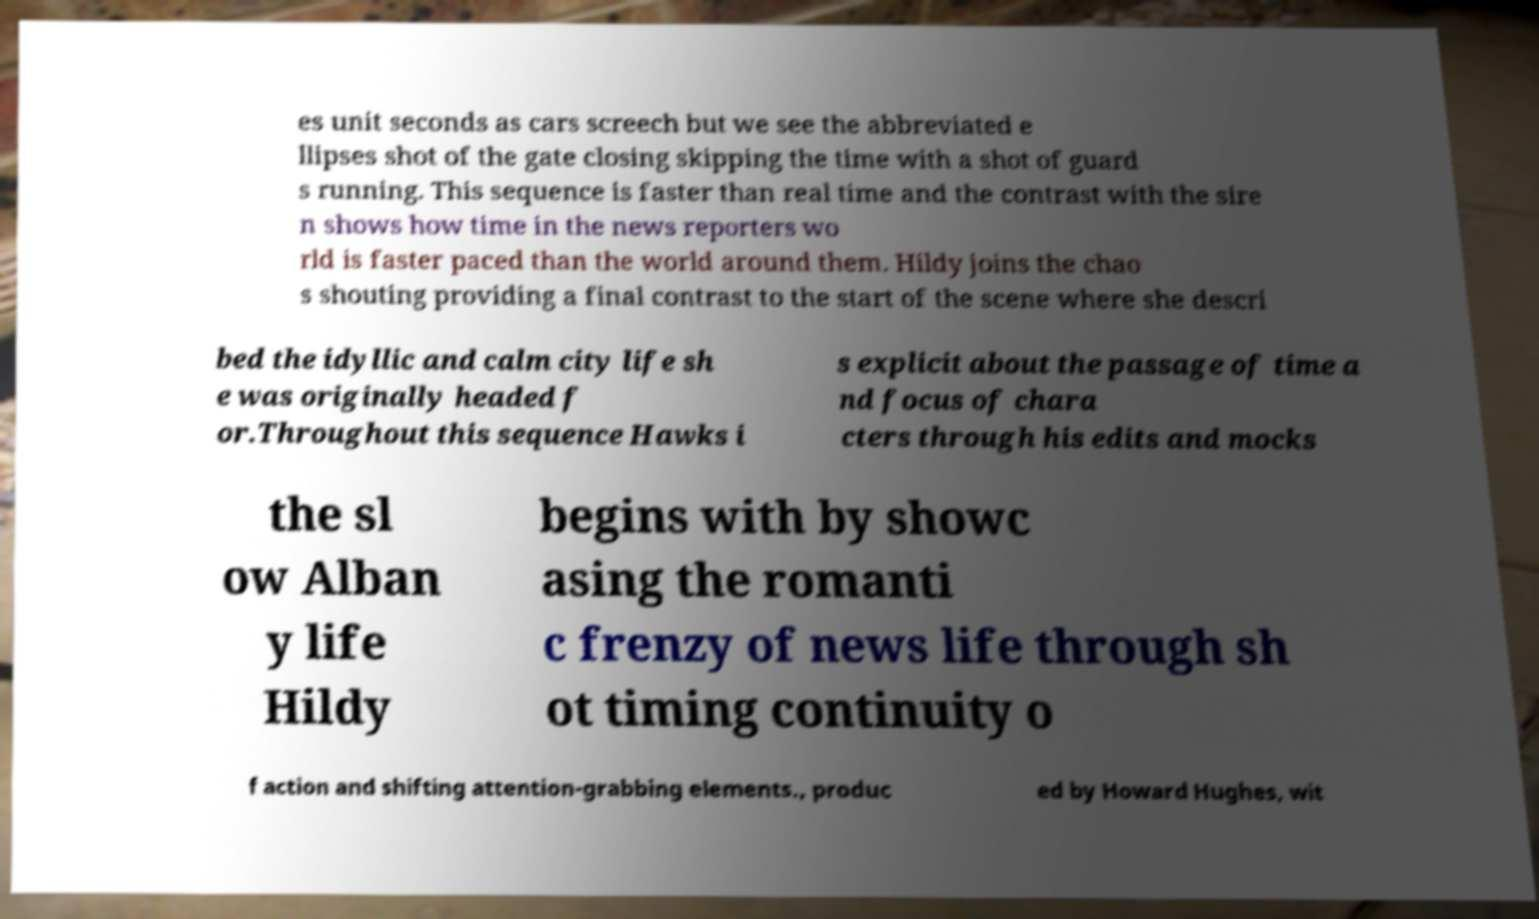Please read and relay the text visible in this image. What does it say? es unit seconds as cars screech but we see the abbreviated e llipses shot of the gate closing skipping the time with a shot of guard s running. This sequence is faster than real time and the contrast with the sire n shows how time in the news reporters wo rld is faster paced than the world around them. Hildy joins the chao s shouting providing a final contrast to the start of the scene where she descri bed the idyllic and calm city life sh e was originally headed f or.Throughout this sequence Hawks i s explicit about the passage of time a nd focus of chara cters through his edits and mocks the sl ow Alban y life Hildy begins with by showc asing the romanti c frenzy of news life through sh ot timing continuity o f action and shifting attention-grabbing elements., produc ed by Howard Hughes, wit 